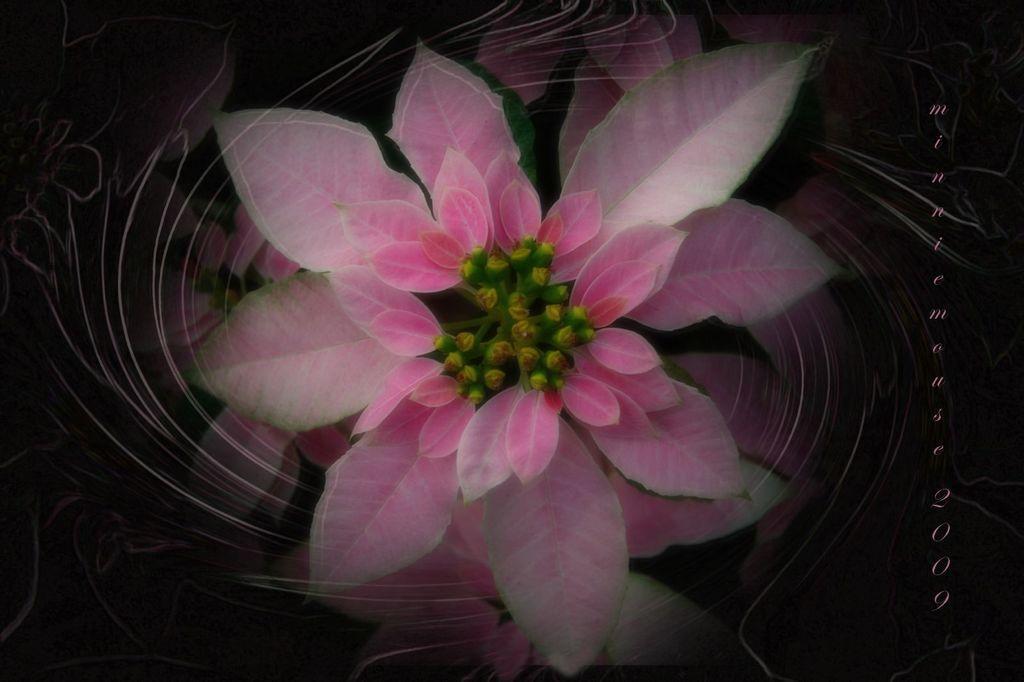Describe this image in one or two sentences. In the picture I can see a plant which is pink in color. The background of the image is dark. On the right side I can see a watermark on the image. 